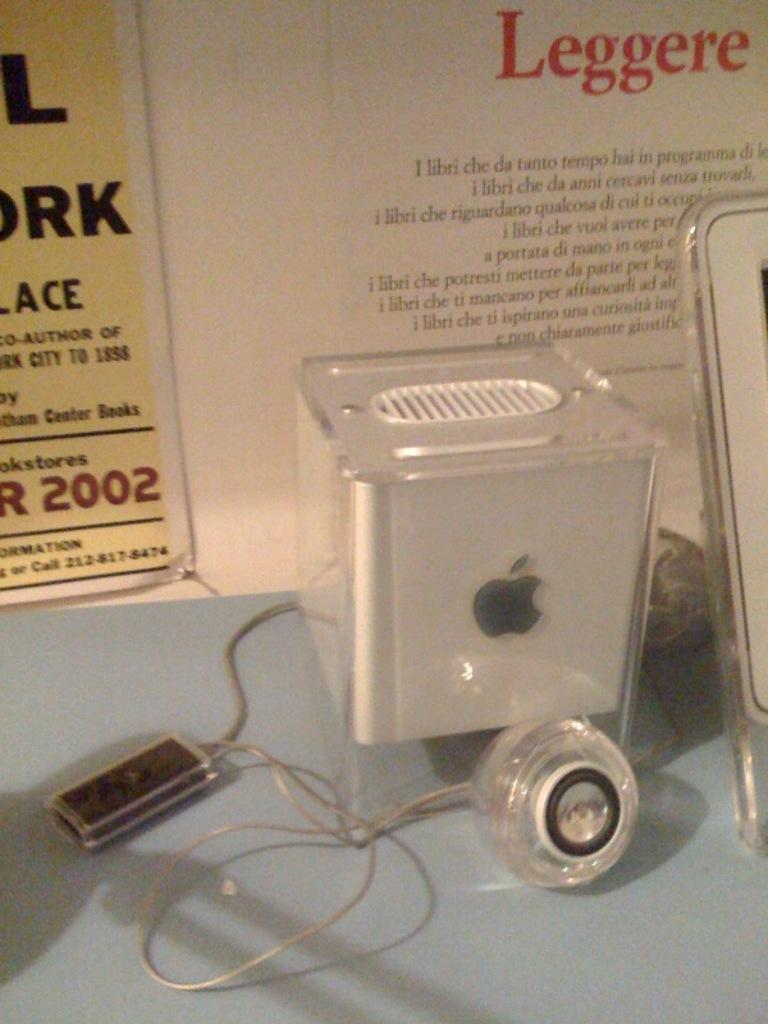What type of object is the main subject in the image? There is an electronic machine in the image. What can be seen in the background of the image? There are posters with text and a wall visible in the background of the image. How many dogs are sitting on the electronic machine in the image? There are no dogs present in the image; it only features an electronic machine and posters with text in the background. 